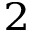Convert formula to latex. <formula><loc_0><loc_0><loc_500><loc_500>_ { 2 }</formula> 